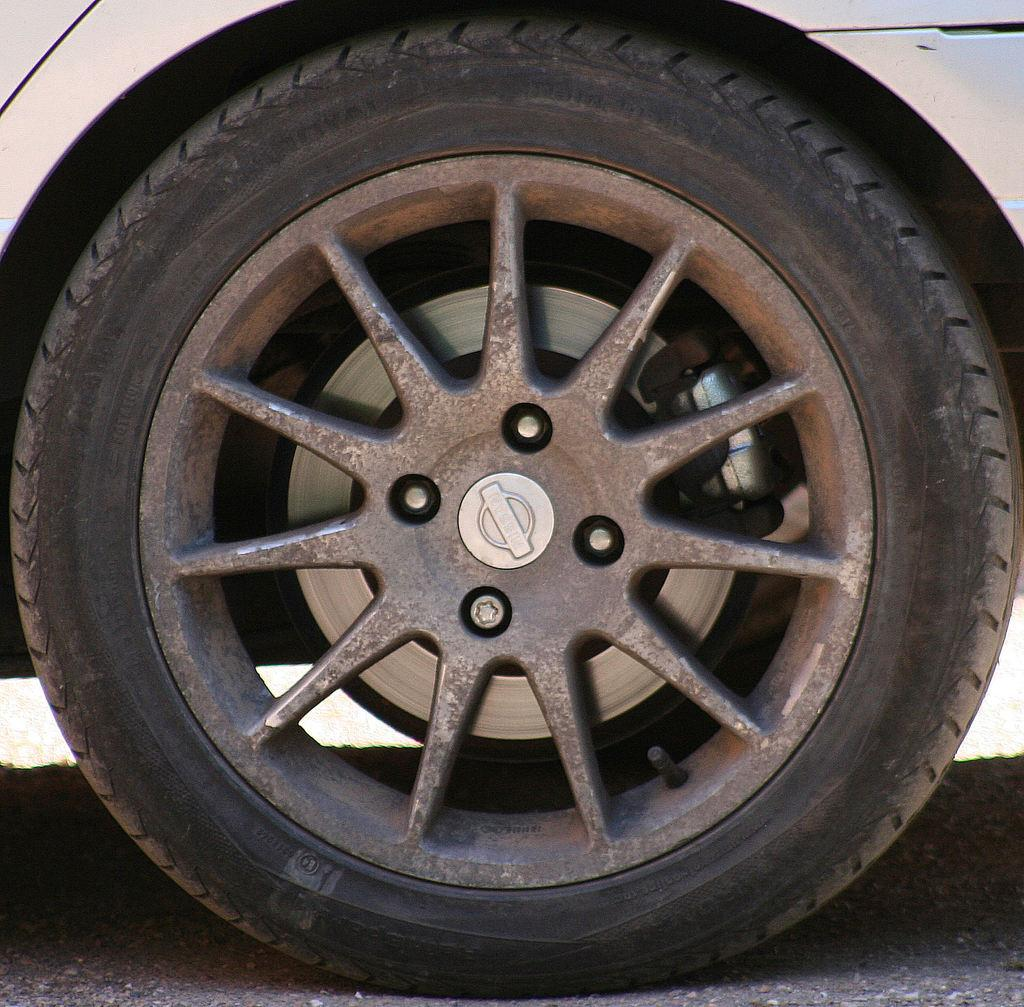What part of a vehicle can be seen in the image? There is a wheel of a vehicle in the image. What color is the vehicle? The vehicle is white. What color is the wheel? The wheel is black. Where is the vehicle located? The vehicle is on the road. What type of meal is being prepared on the stem of the vehicle in the image? There is no meal or stem present in the image; it only features a wheel of a vehicle on the road. 